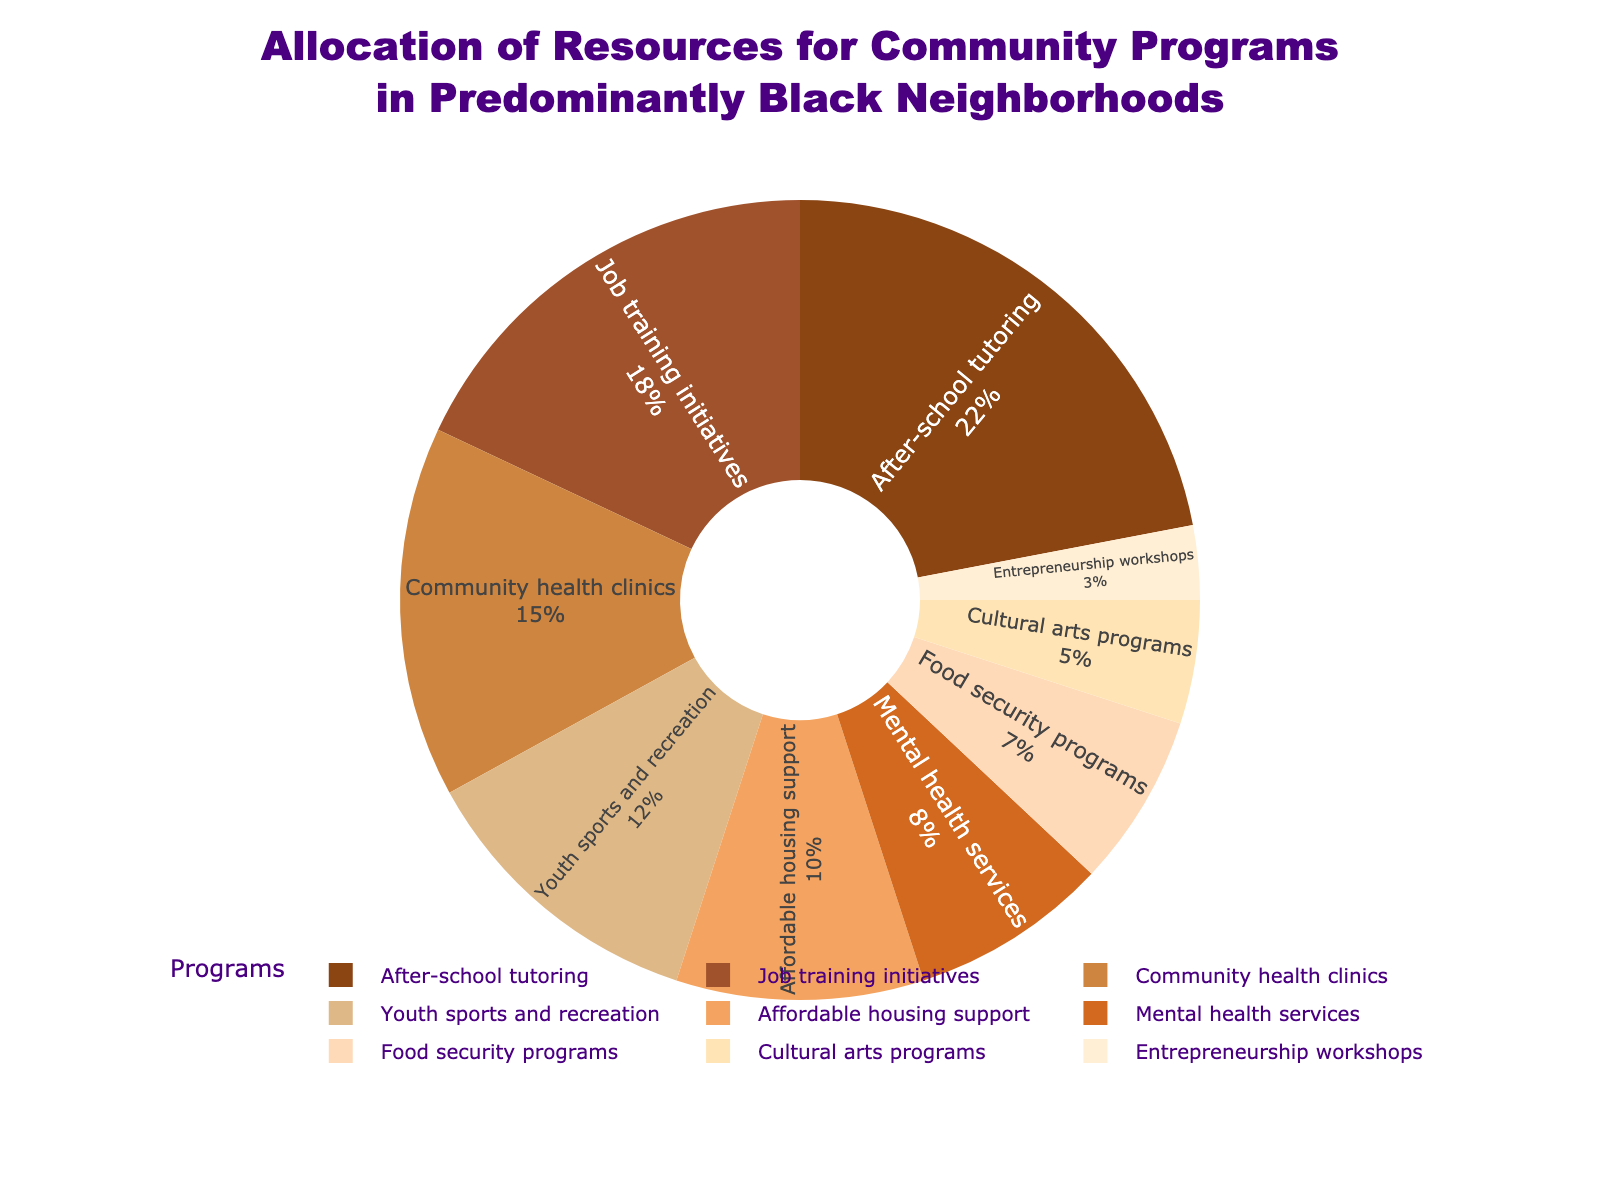What program receives the largest allocation of resources? The largest slice in the pie chart represents after-school tutoring with 22%.
Answer: After-school tutoring How much more is allocated to job training initiatives compared to food security programs? Job training initiatives receive 18%, while food security programs receive 7%. The difference is 18% - 7% = 11%.
Answer: 11% What is the visual insight of the program with the smallest allocation? The smallest slice in the pie chart, colored pale yellow, corresponds to entrepreneurship workshops, which constitutes 3% of the total allocation.
Answer: Entrepreneurship workshops Which color represents mental health services in the pie chart? The allocation for mental health services is represented by a slice in orange.
Answer: Orange Is the allocation for youth sports and recreation greater or less than the allocation for affordable housing support? The slice for youth sports and recreation is 12%, whereas affordable housing support is indicated as 10%. Thus, youth sports and recreation receives a greater allocation.
Answer: Greater What percentage of the total allocation goes toward programs specifically addressing health (community health clinics and mental health services)? Community health clinics receive 15% and mental health services receive 8%. Adding these together gives 15% + 8% = 23%.
Answer: 23% Combine the allocation for cultural arts programs and entrepreneurship workshops and compare it to after-school tutoring. Which is higher? Cultural arts programs receive 5% and entrepreneurship workshops receive 3%. Together they receive 5% + 3% = 8%. After-school tutoring alone receives 22%, which is higher.
Answer: After-school tutoring How much total allocation do the three smallest programs together receive, and what are they? The three smallest programs are food security programs (7%), cultural arts programs (5%), and entrepreneurship workshops (3%). Together, they receive 7% + 5% + 3% = 15%.
Answer: 15% If each program were to receive an equal allocation of 10%, which programs are currently over-allocated and which are under-allocated? Programs over 10% are: after-school tutoring (22%), job training initiatives (18%), community health clinics (15%), youth sports and recreation (12%). Programs under 10% are: affordable housing support (10%), mental health services (8%), food security programs (7%), cultural arts programs (5%), entrepreneurship workshops (3%). Since affordable housing support equals exactly 10%, it fits as neither.
Answer: Over-allocated: after-school tutoring, job training initiatives, community health clinics, youth sports and recreation. Under-allocated: mental health services, food security programs, cultural arts programs, entrepreneurship workshops 